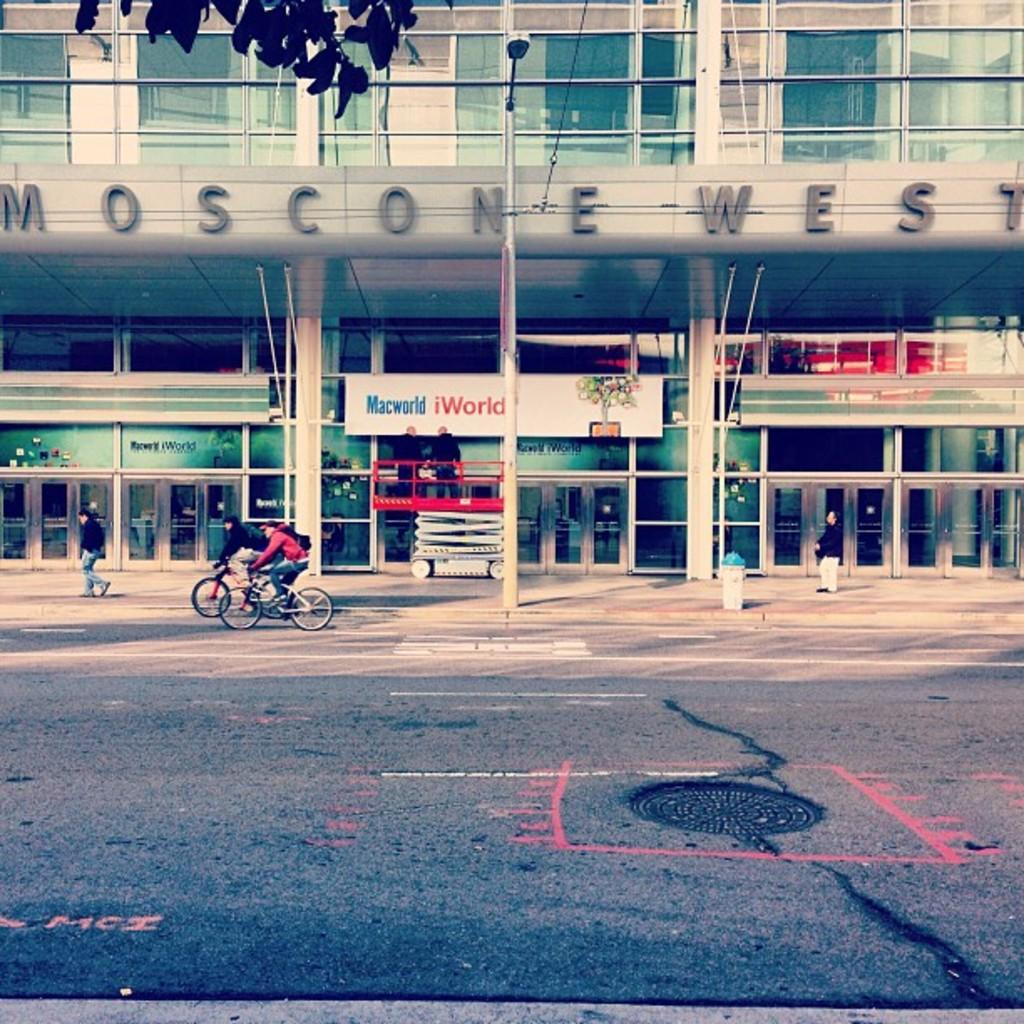How many people are in the image? There are two persons in the image. What are the persons wearing? The persons are wearing clothes. What activity are the persons engaged in? The persons are riding bicycles. Where are the bicycles located in relation to the building? The bicycles are in front of a building. What is visible at the bottom of the image? There is a road at the bottom of the image. How many dogs can be seen playing with an egg in the image? There are no dogs or eggs present in the image. 